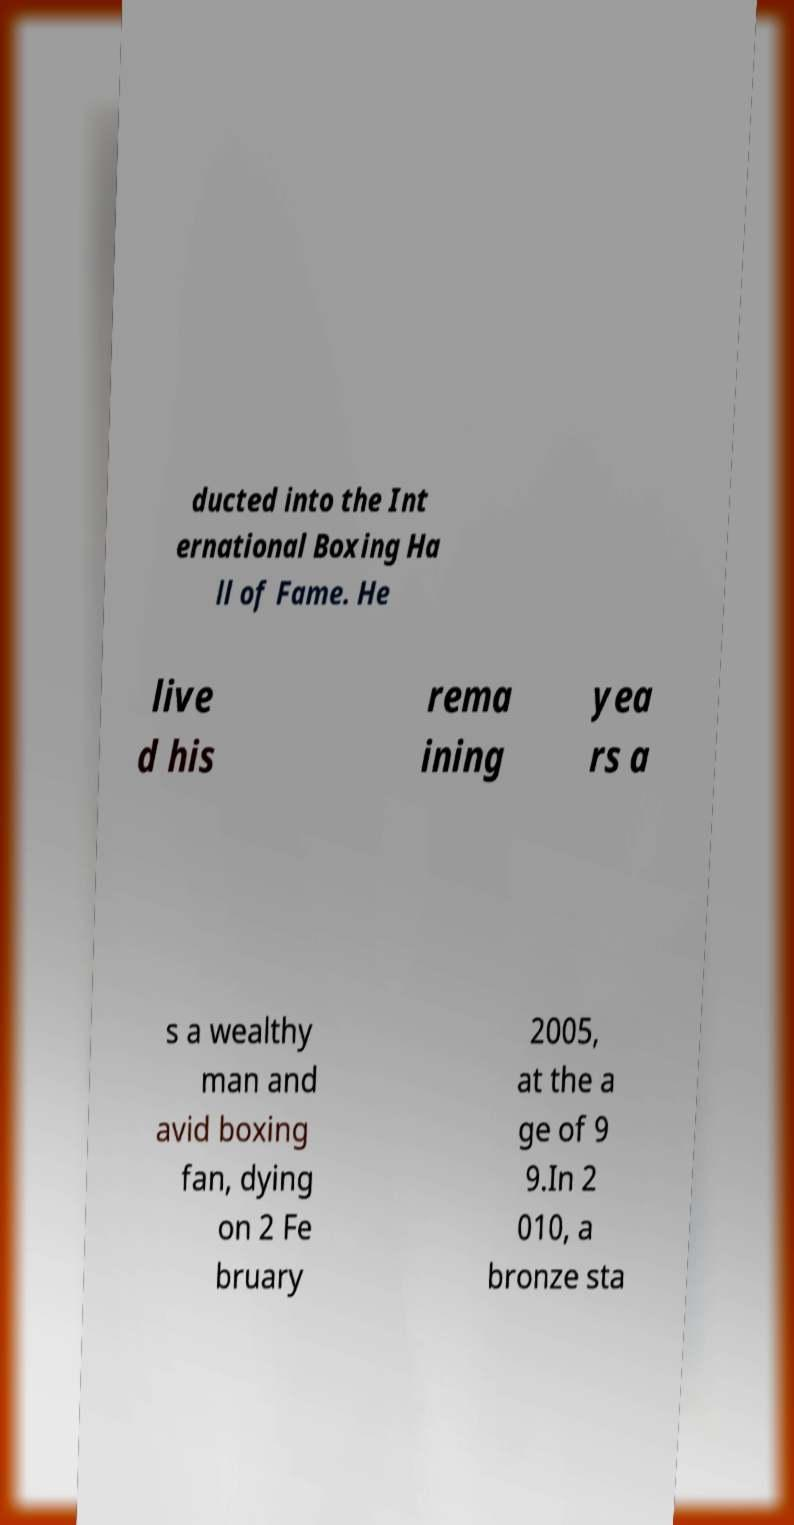There's text embedded in this image that I need extracted. Can you transcribe it verbatim? ducted into the Int ernational Boxing Ha ll of Fame. He live d his rema ining yea rs a s a wealthy man and avid boxing fan, dying on 2 Fe bruary 2005, at the a ge of 9 9.In 2 010, a bronze sta 